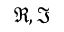Convert formula to latex. <formula><loc_0><loc_0><loc_500><loc_500>\Re , \Im</formula> 